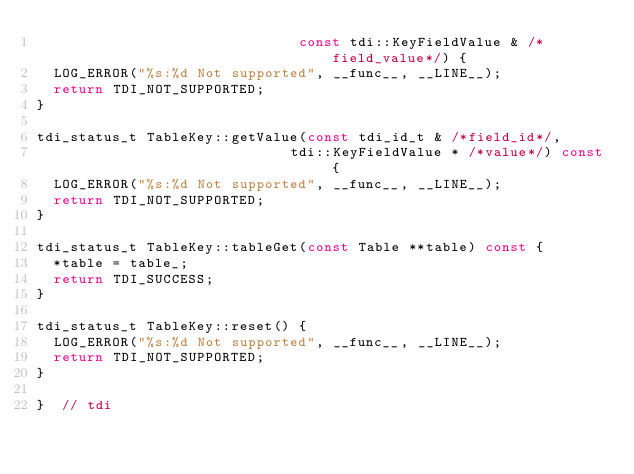Convert code to text. <code><loc_0><loc_0><loc_500><loc_500><_C++_>                               const tdi::KeyFieldValue & /*field_value*/) {
  LOG_ERROR("%s:%d Not supported", __func__, __LINE__);
  return TDI_NOT_SUPPORTED;
}

tdi_status_t TableKey::getValue(const tdi_id_t & /*field_id*/,
                              tdi::KeyFieldValue * /*value*/) const {
  LOG_ERROR("%s:%d Not supported", __func__, __LINE__);
  return TDI_NOT_SUPPORTED;
}

tdi_status_t TableKey::tableGet(const Table **table) const {
  *table = table_;
  return TDI_SUCCESS;
}

tdi_status_t TableKey::reset() {
  LOG_ERROR("%s:%d Not supported", __func__, __LINE__);
  return TDI_NOT_SUPPORTED;
}

}  // tdi

</code> 